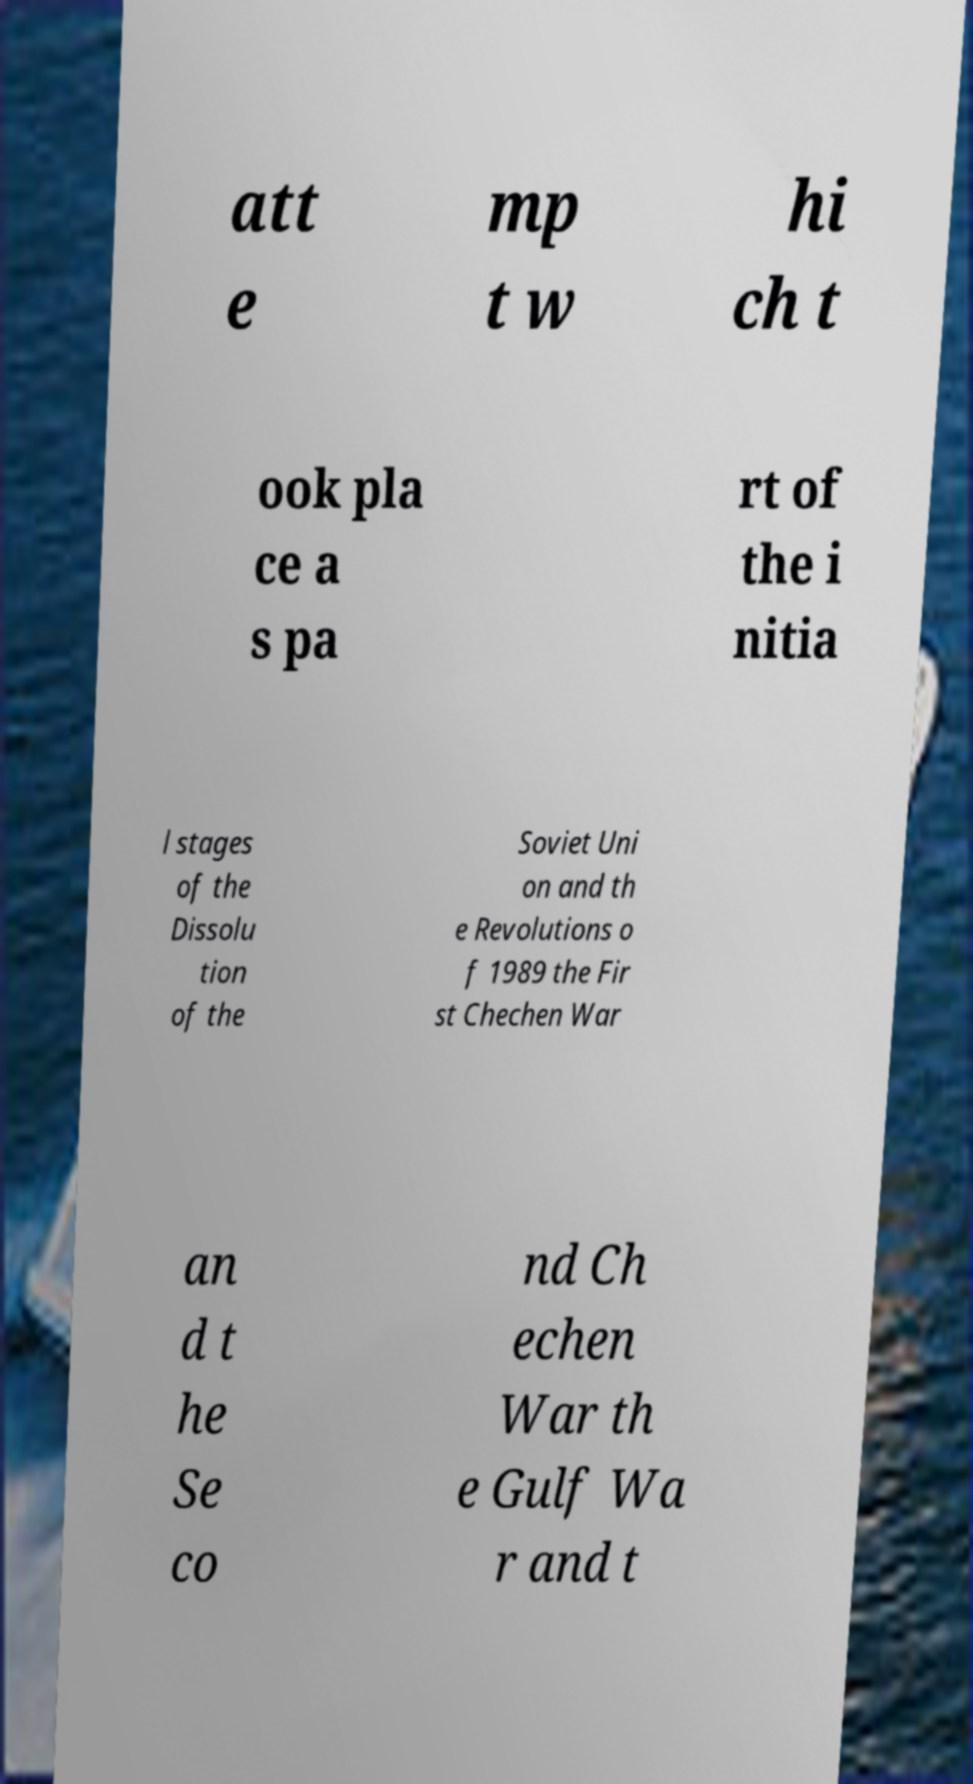Could you assist in decoding the text presented in this image and type it out clearly? att e mp t w hi ch t ook pla ce a s pa rt of the i nitia l stages of the Dissolu tion of the Soviet Uni on and th e Revolutions o f 1989 the Fir st Chechen War an d t he Se co nd Ch echen War th e Gulf Wa r and t 